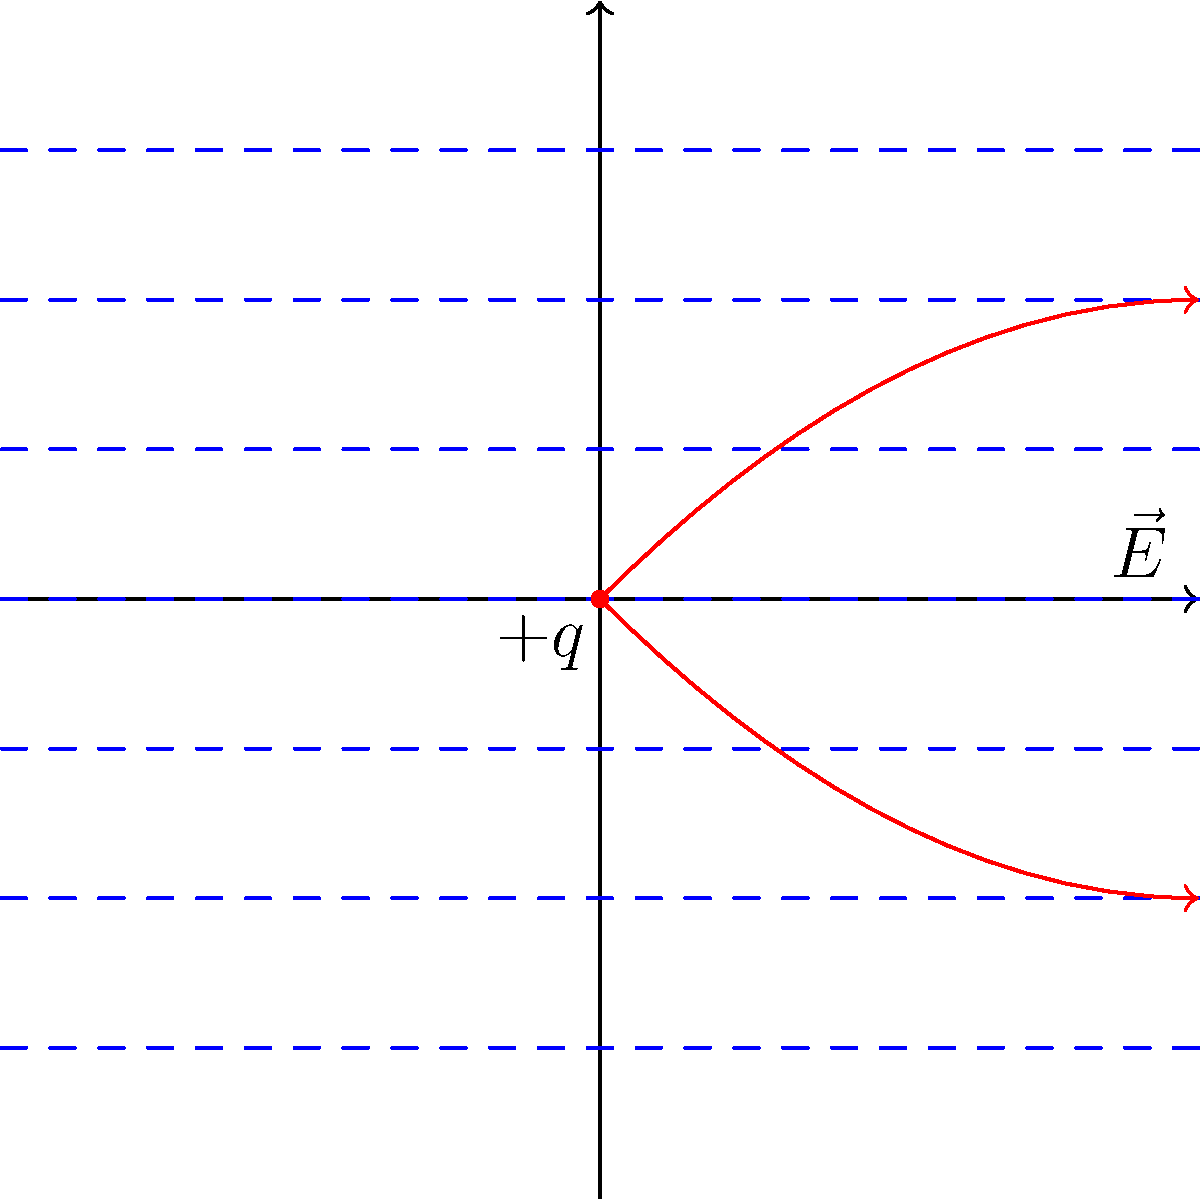In the context of electromagnetic field visualization, consider a positive point charge $+q$ placed in a uniform electric field $\vec{E}$ directed to the right, as shown in the figure. How does the presence of the point charge affect the overall electric field pattern, and what medical imaging technique utilizes a similar principle of field distortion for diagnostics? To answer this question, let's break it down into steps:

1. Field pattern analysis:
   a) The uniform electric field is represented by parallel, equally spaced lines pointing to the right.
   b) The positive point charge creates its own radial electric field, pointing outward in all directions.
   c) The resulting field is a superposition of these two fields.

2. Field distortion:
   a) Near the point charge, the field lines are bent away from their original parallel configuration.
   b) The field strength increases on the right side of the charge (constructive interference).
   c) The field strength decreases on the left side of the charge (destructive interference).

3. Medical imaging analogy:
   Magnetic Resonance Imaging (MRI) utilizes a similar principle of field distortion:
   a) MRI uses a strong, uniform magnetic field to align protons in the body.
   b) Radio frequency (RF) pulses are used to excite these protons, causing them to emit signals.
   c) Different tissues distort the local magnetic field differently, similar to how the point charge distorts the electric field.
   d) These distortions result in varying signal intensities, which are used to create detailed images of body structures.

4. Clinical relevance:
   Understanding field distortions is crucial in interpreting MRI images, as it helps medical professionals:
   a) Differentiate between normal and abnormal tissues.
   b) Identify subtle changes in tissue composition or structure.
   c) Diagnose various conditions, including tumors, inflammation, and structural abnormalities.
Answer: The point charge distorts the uniform field, creating a superposition of fields. MRI uses a similar principle of field distortion for diagnostic imaging. 